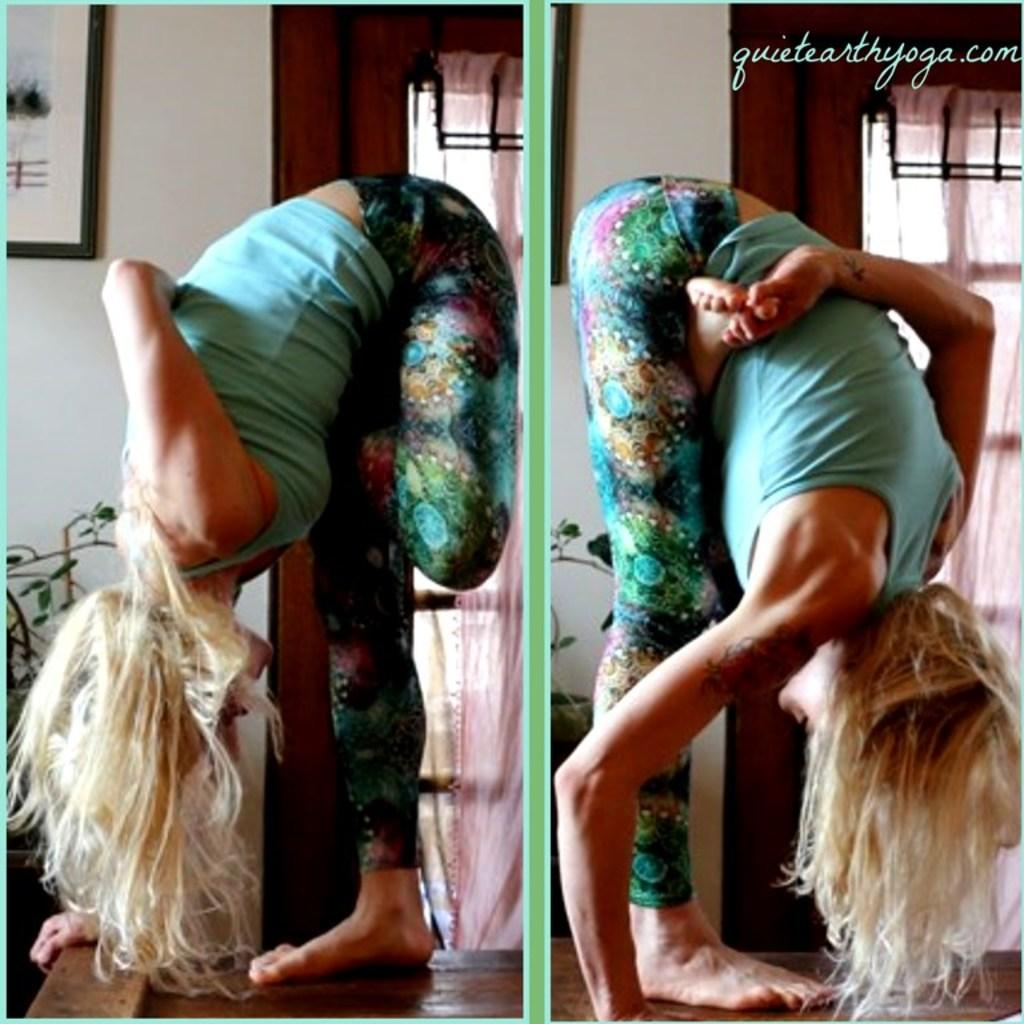What is the composition of the image? The image is a collage of two different pictures of the same person. What can be observed about the person's attire in the image? The person is wearing clothes. What activity is the person engaged in? The person is doing stretching exercises. Where are the exercises being performed? The exercises are performed in front of a window. Are there any women wearing scarves in the image? There is no mention of women or scarves in the provided facts, so we cannot determine their presence in the image. --- Facts: 1. There is a person sitting on a chair in the image. 2. The person is holding a book. 3. The book has a blue cover. 4. The chair is made of wood. 5. There is a table next to the chair. Absurd Topics: parrot, ocean, bicycle Conversation: What is the person in the image doing? The person is sitting on a chair in the image. What object is the person holding? The person is holding a book. What is the color of the book's cover? The book has a blue cover. What material is the chair made of? The chair is made of wood. What is located next to the chair? There is a table next to the chair. Reasoning: Let's think step by step in order to produce the conversation. We start by describing the person's position and activity, which is sitting on a chair. Then, we mention the object the person is holding, which is a book. Next, we provide information about the book's appearance, specifically its blue cover. We then describe the chair's material, which is wood. Finally, we mention the presence of a table next to the chair. Absurd Question/Answer: Can you see a parrot sitting on the person's shoulder in the image? There is no mention of a parrot in the provided facts, so we cannot determine its presence in the image. 